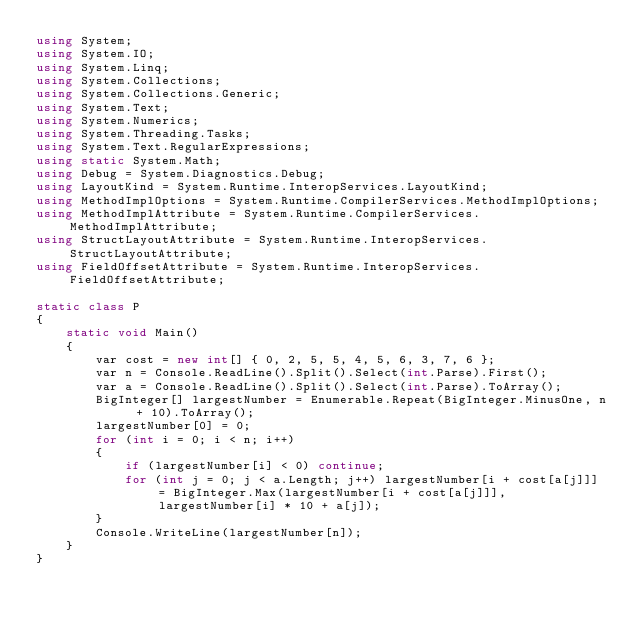Convert code to text. <code><loc_0><loc_0><loc_500><loc_500><_C#_>using System;
using System.IO;
using System.Linq;
using System.Collections;
using System.Collections.Generic;
using System.Text;
using System.Numerics;
using System.Threading.Tasks;
using System.Text.RegularExpressions;
using static System.Math;
using Debug = System.Diagnostics.Debug;
using LayoutKind = System.Runtime.InteropServices.LayoutKind;
using MethodImplOptions = System.Runtime.CompilerServices.MethodImplOptions;
using MethodImplAttribute = System.Runtime.CompilerServices.MethodImplAttribute;
using StructLayoutAttribute = System.Runtime.InteropServices.StructLayoutAttribute;
using FieldOffsetAttribute = System.Runtime.InteropServices.FieldOffsetAttribute;

static class P
{
    static void Main()
    {
        var cost = new int[] { 0, 2, 5, 5, 4, 5, 6, 3, 7, 6 };
        var n = Console.ReadLine().Split().Select(int.Parse).First();
        var a = Console.ReadLine().Split().Select(int.Parse).ToArray();
        BigInteger[] largestNumber = Enumerable.Repeat(BigInteger.MinusOne, n + 10).ToArray();
        largestNumber[0] = 0;
        for (int i = 0; i < n; i++)
        {
            if (largestNumber[i] < 0) continue;
            for (int j = 0; j < a.Length; j++) largestNumber[i + cost[a[j]]] = BigInteger.Max(largestNumber[i + cost[a[j]]], largestNumber[i] * 10 + a[j]);
        }
        Console.WriteLine(largestNumber[n]);
    }
}
</code> 